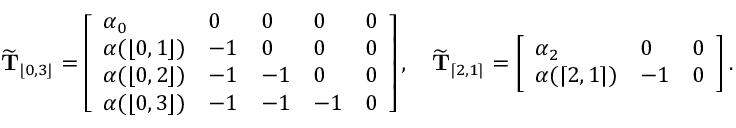Convert formula to latex. <formula><loc_0><loc_0><loc_500><loc_500>\widetilde { T } _ { \lfloor 0 , 3 \rfloor } = \left [ \begin{array} { l l l l l } { \alpha _ { 0 } } & { 0 } & { 0 } & { 0 } & { 0 } \\ { \alpha ( \lfloor 0 , 1 \rfloor ) } & { - 1 } & { 0 } & { 0 } & { 0 } \\ { \alpha ( \lfloor 0 , 2 \rfloor ) } & { - 1 } & { - 1 } & { 0 } & { 0 } \\ { \alpha ( \lfloor 0 , 3 \rfloor ) } & { - 1 } & { - 1 } & { - 1 } & { 0 } \end{array} \right ] , \quad \widetilde { T } _ { \lceil 2 , 1 \rceil } = \left [ \begin{array} { l l l } { \alpha _ { 2 } } & { 0 } & { 0 } \\ { \alpha ( \lceil 2 , 1 \rceil ) } & { - 1 } & { 0 } \end{array} \right ] .</formula> 